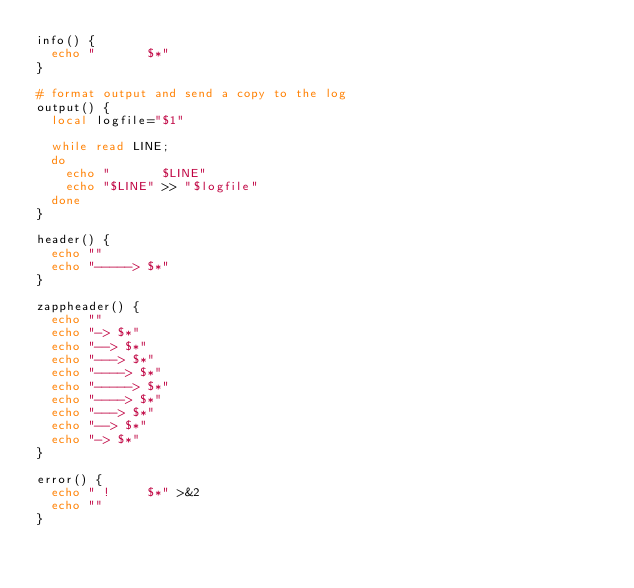<code> <loc_0><loc_0><loc_500><loc_500><_Bash_>info() {
  echo "       $*"
}

# format output and send a copy to the log
output() {
  local logfile="$1"

  while read LINE;
  do
    echo "       $LINE"
    echo "$LINE" >> "$logfile"
  done
}

header() {
  echo ""
  echo "-----> $*"
}

zappheader() {
  echo ""
  echo "-> $*"
  echo "--> $*"
  echo "---> $*"
  echo "----> $*"
  echo "-----> $*"
  echo "----> $*"
  echo "---> $*"
  echo "--> $*"
  echo "-> $*"
}

error() {
  echo " !     $*" >&2
  echo ""
}
</code> 